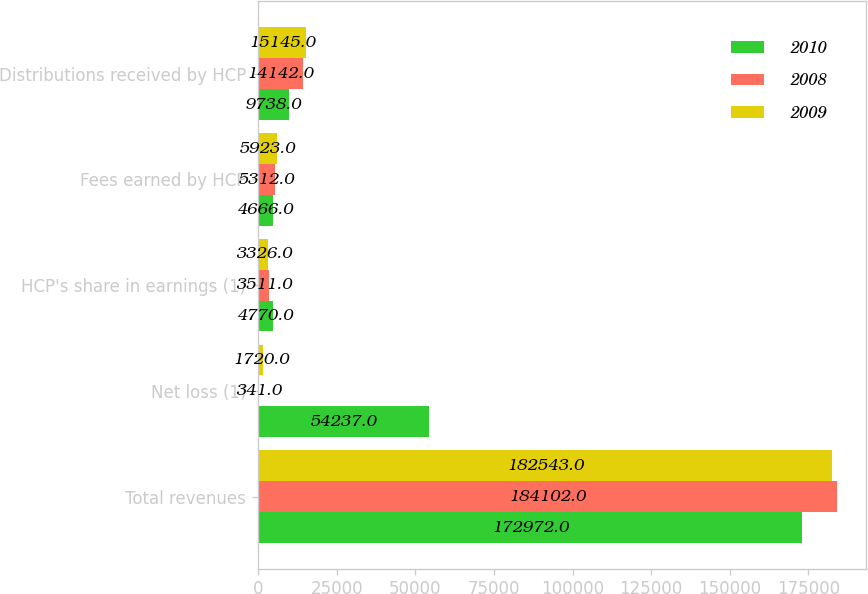<chart> <loc_0><loc_0><loc_500><loc_500><stacked_bar_chart><ecel><fcel>Total revenues<fcel>Net loss (1)<fcel>HCP's share in earnings (1)<fcel>Fees earned by HCP<fcel>Distributions received by HCP<nl><fcel>2010<fcel>172972<fcel>54237<fcel>4770<fcel>4666<fcel>9738<nl><fcel>2008<fcel>184102<fcel>341<fcel>3511<fcel>5312<fcel>14142<nl><fcel>2009<fcel>182543<fcel>1720<fcel>3326<fcel>5923<fcel>15145<nl></chart> 